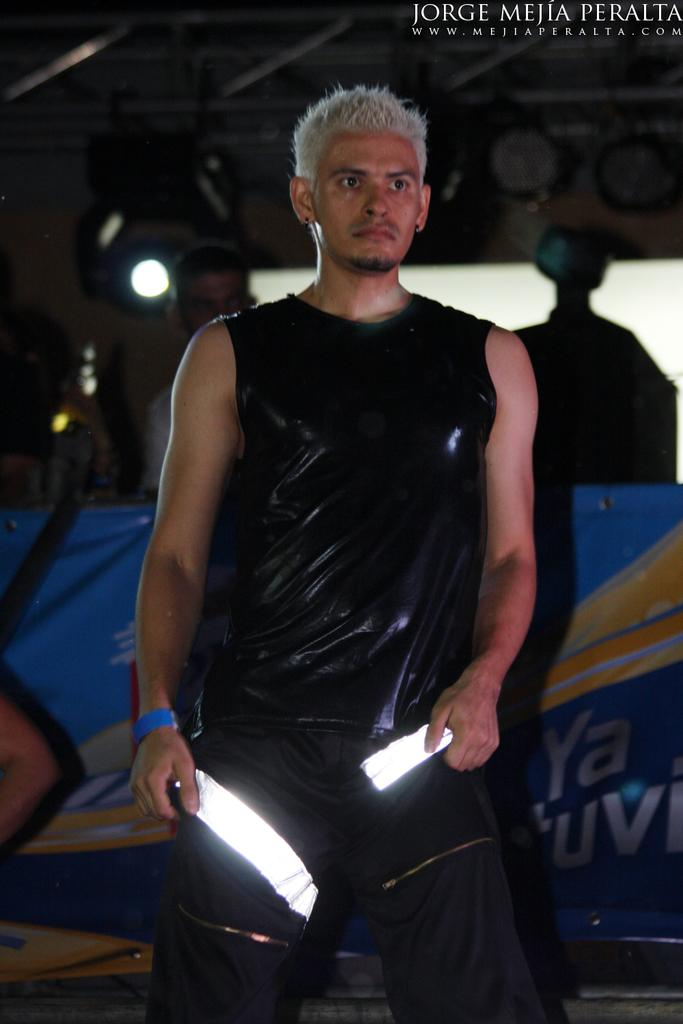<image>
Provide a brief description of the given image. A man dressed in black and holding blades poses in this Jorge Mejia Peralta photo. 